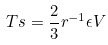Convert formula to latex. <formula><loc_0><loc_0><loc_500><loc_500>T s = \frac { 2 } { 3 } r ^ { - 1 } \epsilon V</formula> 